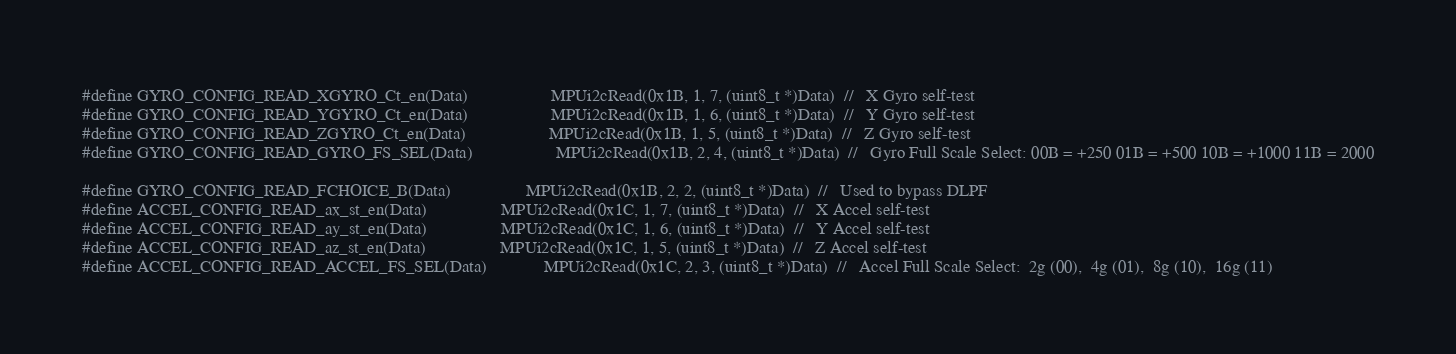<code> <loc_0><loc_0><loc_500><loc_500><_C_>#define GYRO_CONFIG_READ_XGYRO_Ct_en(Data)					MPUi2cRead(0x1B, 1, 7, (uint8_t *)Data)  //   X Gyro self-test
#define GYRO_CONFIG_READ_YGYRO_Ct_en(Data)					MPUi2cRead(0x1B, 1, 6, (uint8_t *)Data)  //   Y Gyro self-test
#define GYRO_CONFIG_READ_ZGYRO_Ct_en(Data)					MPUi2cRead(0x1B, 1, 5, (uint8_t *)Data)  //   Z Gyro self-test
#define GYRO_CONFIG_READ_GYRO_FS_SEL(Data)					MPUi2cRead(0x1B, 2, 4, (uint8_t *)Data)  //   Gyro Full Scale Select: 00B = +250 01B = +500 10B = +1000 11B = 2000

#define GYRO_CONFIG_READ_FCHOICE_B(Data)					MPUi2cRead(0x1B, 2, 2, (uint8_t *)Data)  //   Used to bypass DLPF
#define ACCEL_CONFIG_READ_ax_st_en(Data)					MPUi2cRead(0x1C, 1, 7, (uint8_t *)Data)  //   X Accel self-test
#define ACCEL_CONFIG_READ_ay_st_en(Data)					MPUi2cRead(0x1C, 1, 6, (uint8_t *)Data)  //   Y Accel self-test
#define ACCEL_CONFIG_READ_az_st_en(Data)					MPUi2cRead(0x1C, 1, 5, (uint8_t *)Data)  //   Z Accel self-test
#define ACCEL_CONFIG_READ_ACCEL_FS_SEL(Data)				MPUi2cRead(0x1C, 2, 3, (uint8_t *)Data)  //   Accel Full Scale Select:  2g (00),  4g (01),  8g (10),  16g (11)

</code> 